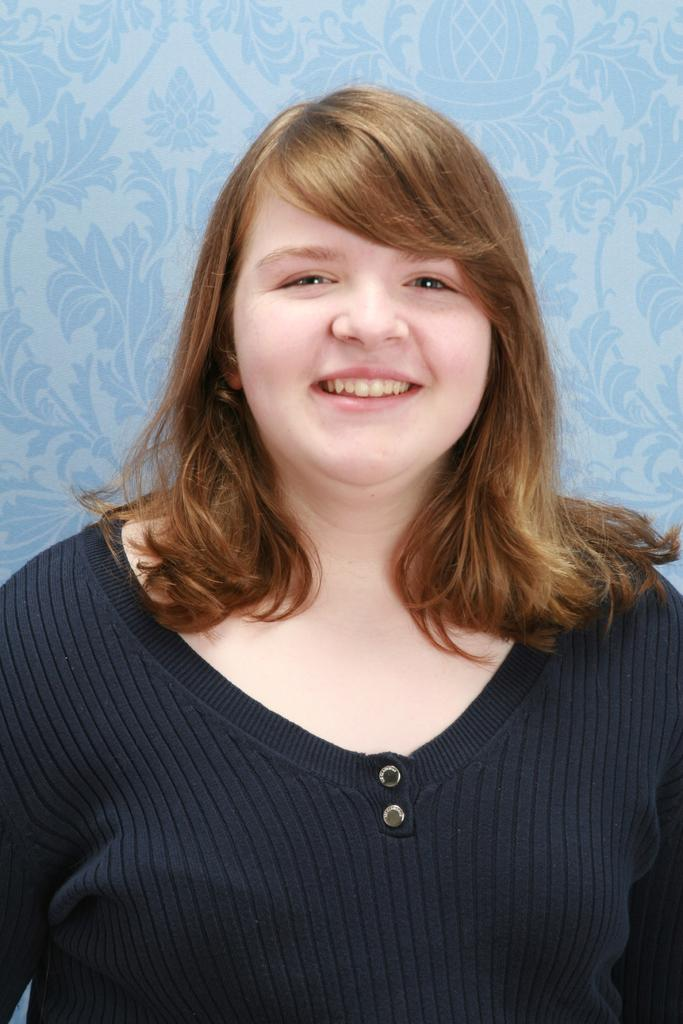What is the main subject of the image? There is a person in the image. What is the person wearing? The person is wearing a black t-shirt. What expression does the person have? The person is smiling. What color is the background of the image? The background of the image is blue. What type of reward is the person holding in the image? There is no reward visible in the image; the person is simply wearing a black t-shirt and smiling. 